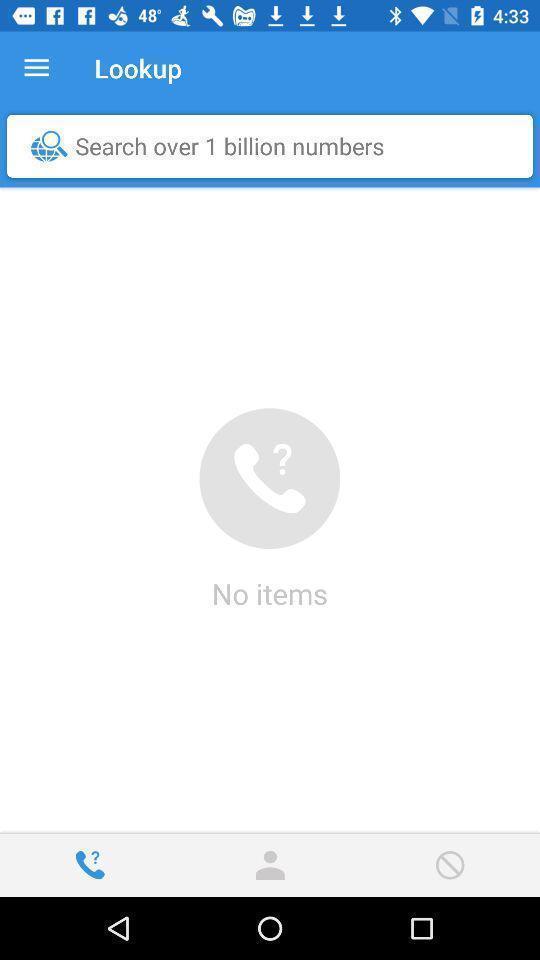Tell me what you see in this picture. Search option to find information using numbers. 